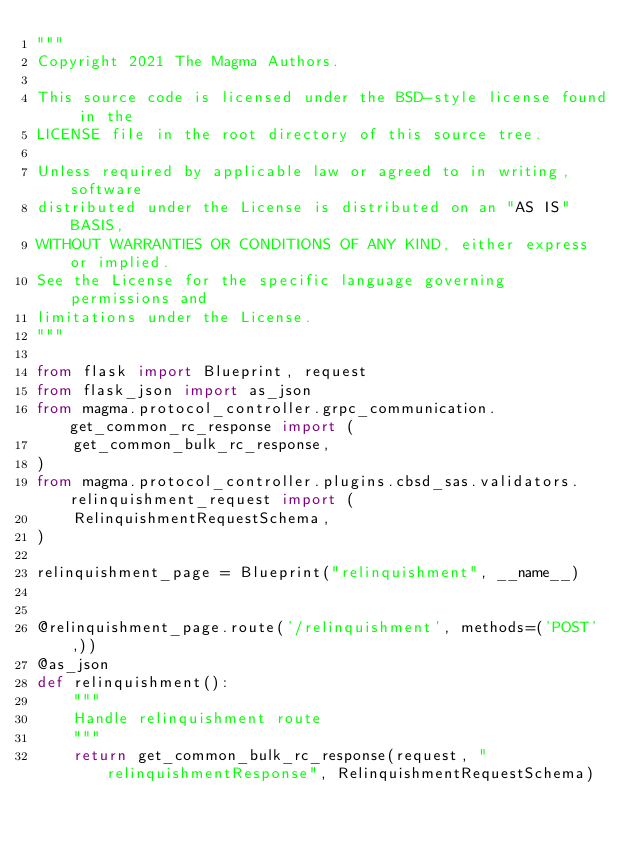Convert code to text. <code><loc_0><loc_0><loc_500><loc_500><_Python_>"""
Copyright 2021 The Magma Authors.

This source code is licensed under the BSD-style license found in the
LICENSE file in the root directory of this source tree.

Unless required by applicable law or agreed to in writing, software
distributed under the License is distributed on an "AS IS" BASIS,
WITHOUT WARRANTIES OR CONDITIONS OF ANY KIND, either express or implied.
See the License for the specific language governing permissions and
limitations under the License.
"""

from flask import Blueprint, request
from flask_json import as_json
from magma.protocol_controller.grpc_communication.get_common_rc_response import (
    get_common_bulk_rc_response,
)
from magma.protocol_controller.plugins.cbsd_sas.validators.relinquishment_request import (
    RelinquishmentRequestSchema,
)

relinquishment_page = Blueprint("relinquishment", __name__)


@relinquishment_page.route('/relinquishment', methods=('POST',))
@as_json
def relinquishment():
    """
    Handle relinquishment route
    """
    return get_common_bulk_rc_response(request, "relinquishmentResponse", RelinquishmentRequestSchema)
</code> 